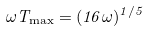<formula> <loc_0><loc_0><loc_500><loc_500>\omega T _ { \max } = ( 1 6 \omega ) ^ { 1 / 5 }</formula> 